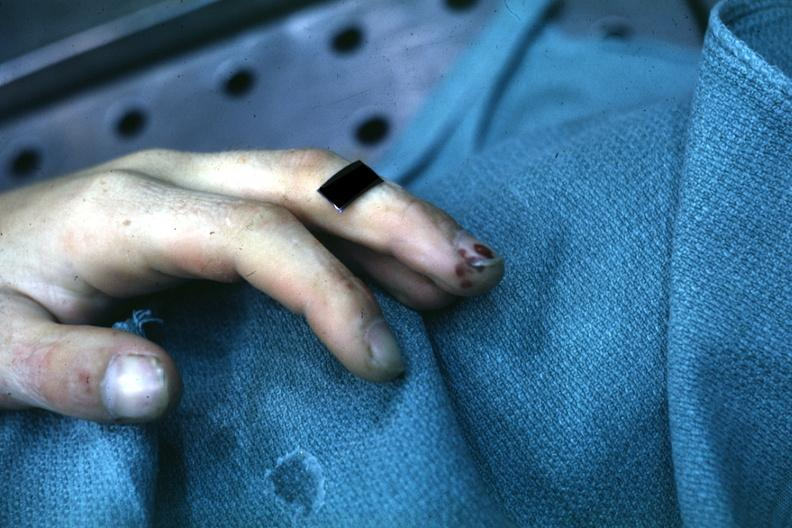what is present?
Answer the question using a single word or phrase. Digital infarcts bacterial endocarditis 